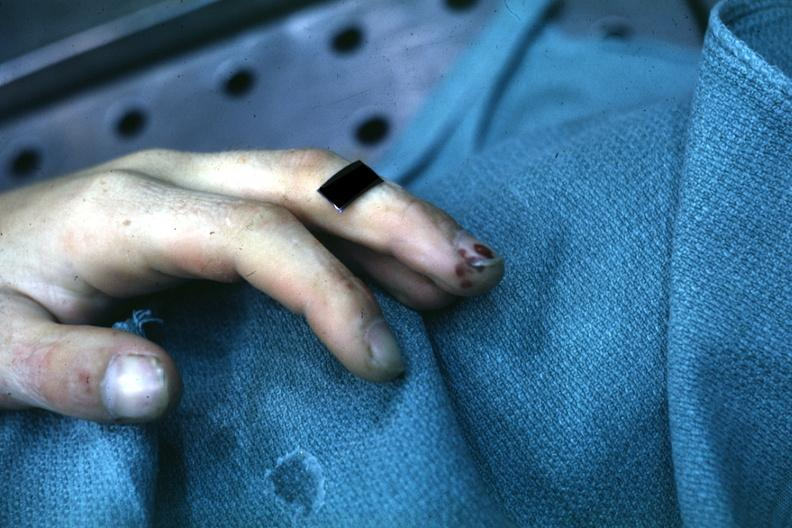what is present?
Answer the question using a single word or phrase. Digital infarcts bacterial endocarditis 